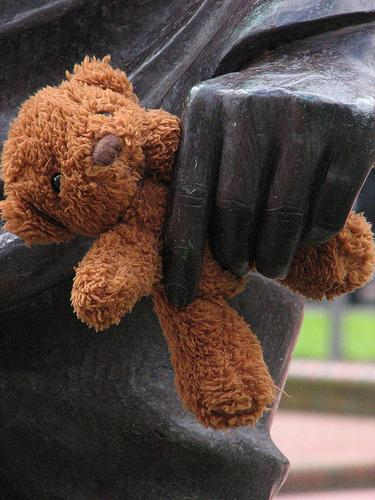Identify an imperfection or feature that shows wear on the teddy bear. There's a string on the teddy bear that appears to be frayed. Can you describe the physical contact between the statue's hand and the teddy bear? The statue's index, middle, and pinky fingers are touching or holding the teddy bear. In the context of a product advertisement, how would you promote the teddy bear? Introducing our soft and cuddly brown teddy bear, featuring adorable button eyes, a cute brown nose, and shaggy fur for endless warm embraces. Which objects are being held by the statue? A brown teddy bear is being held by the statue's hand. Can you provide a brief visual summary of the image for a referential expression grounding task? The image shows a black statue's hand holding a brown teddy bear with black eyes, a brown nose, and shaggy fur, with intricate details evident on the statue's fingers. Mention an intricate detail found on the statue's hand. There are visibly intricate details on the statue's knuckles and fingernail. What can you tell me about the texture of the teddy bear's fur? The teddy bear has shaggy brown fur and appears to be made of a stuffed material. For a multi-choice VQA task, select the most accurate description of the teddy bear's eyes. b) Plastic button eyes What can be observed on the pavement behind the statue? There is a step down visible on the pavement behind the statue. Identify an accessory or detail on the teddy bear's face. The teddy bear has a dark brown nose and two black button eyes. 